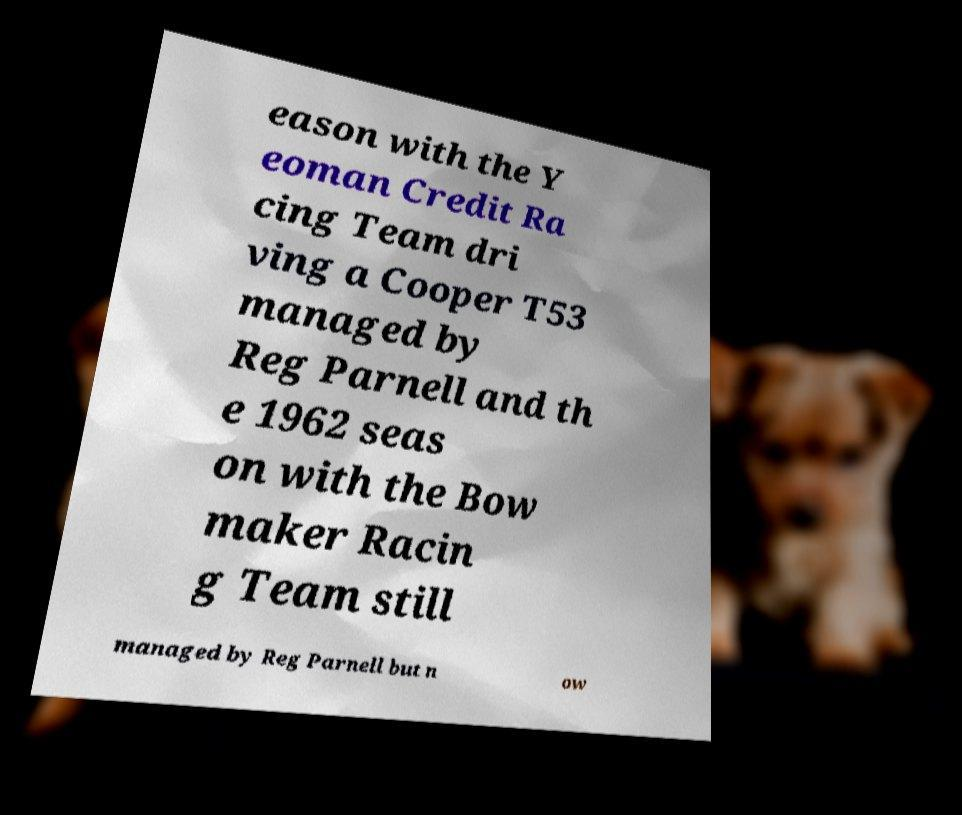Can you accurately transcribe the text from the provided image for me? eason with the Y eoman Credit Ra cing Team dri ving a Cooper T53 managed by Reg Parnell and th e 1962 seas on with the Bow maker Racin g Team still managed by Reg Parnell but n ow 